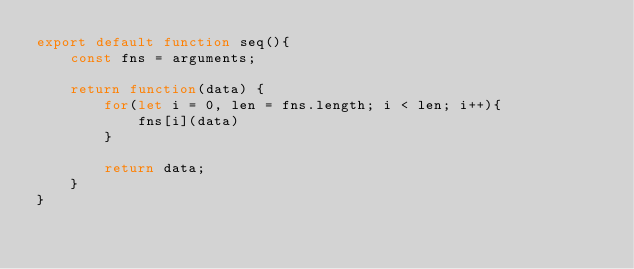<code> <loc_0><loc_0><loc_500><loc_500><_JavaScript_>export default function seq(){
    const fns = arguments;

    return function(data) {
        for(let i = 0, len = fns.length; i < len; i++){
            fns[i](data)
        }

        return data;
    }
}</code> 